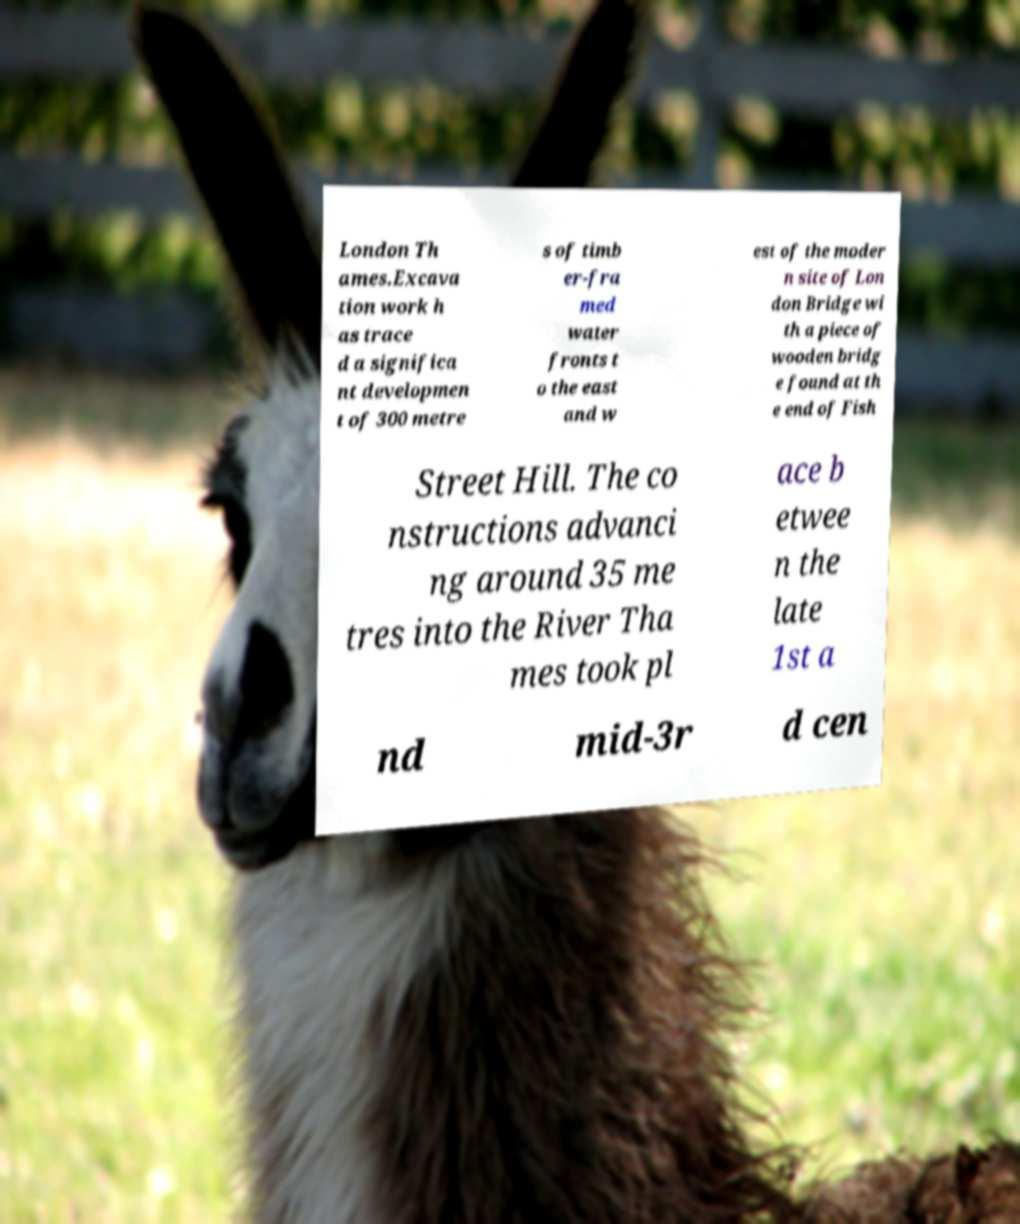Can you read and provide the text displayed in the image?This photo seems to have some interesting text. Can you extract and type it out for me? London Th ames.Excava tion work h as trace d a significa nt developmen t of 300 metre s of timb er-fra med water fronts t o the east and w est of the moder n site of Lon don Bridge wi th a piece of wooden bridg e found at th e end of Fish Street Hill. The co nstructions advanci ng around 35 me tres into the River Tha mes took pl ace b etwee n the late 1st a nd mid-3r d cen 